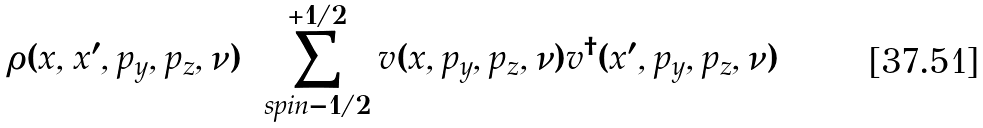Convert formula to latex. <formula><loc_0><loc_0><loc_500><loc_500>\rho ( x , x ^ { \prime } , p _ { y } , p _ { z } , \nu ) = \sum _ { s p i n = - 1 / 2 } ^ { + 1 / 2 } v ( x , p _ { y } , p _ { z } , \nu ) v ^ { \dagger } ( x ^ { \prime } , p _ { y } , p _ { z } , \nu )</formula> 